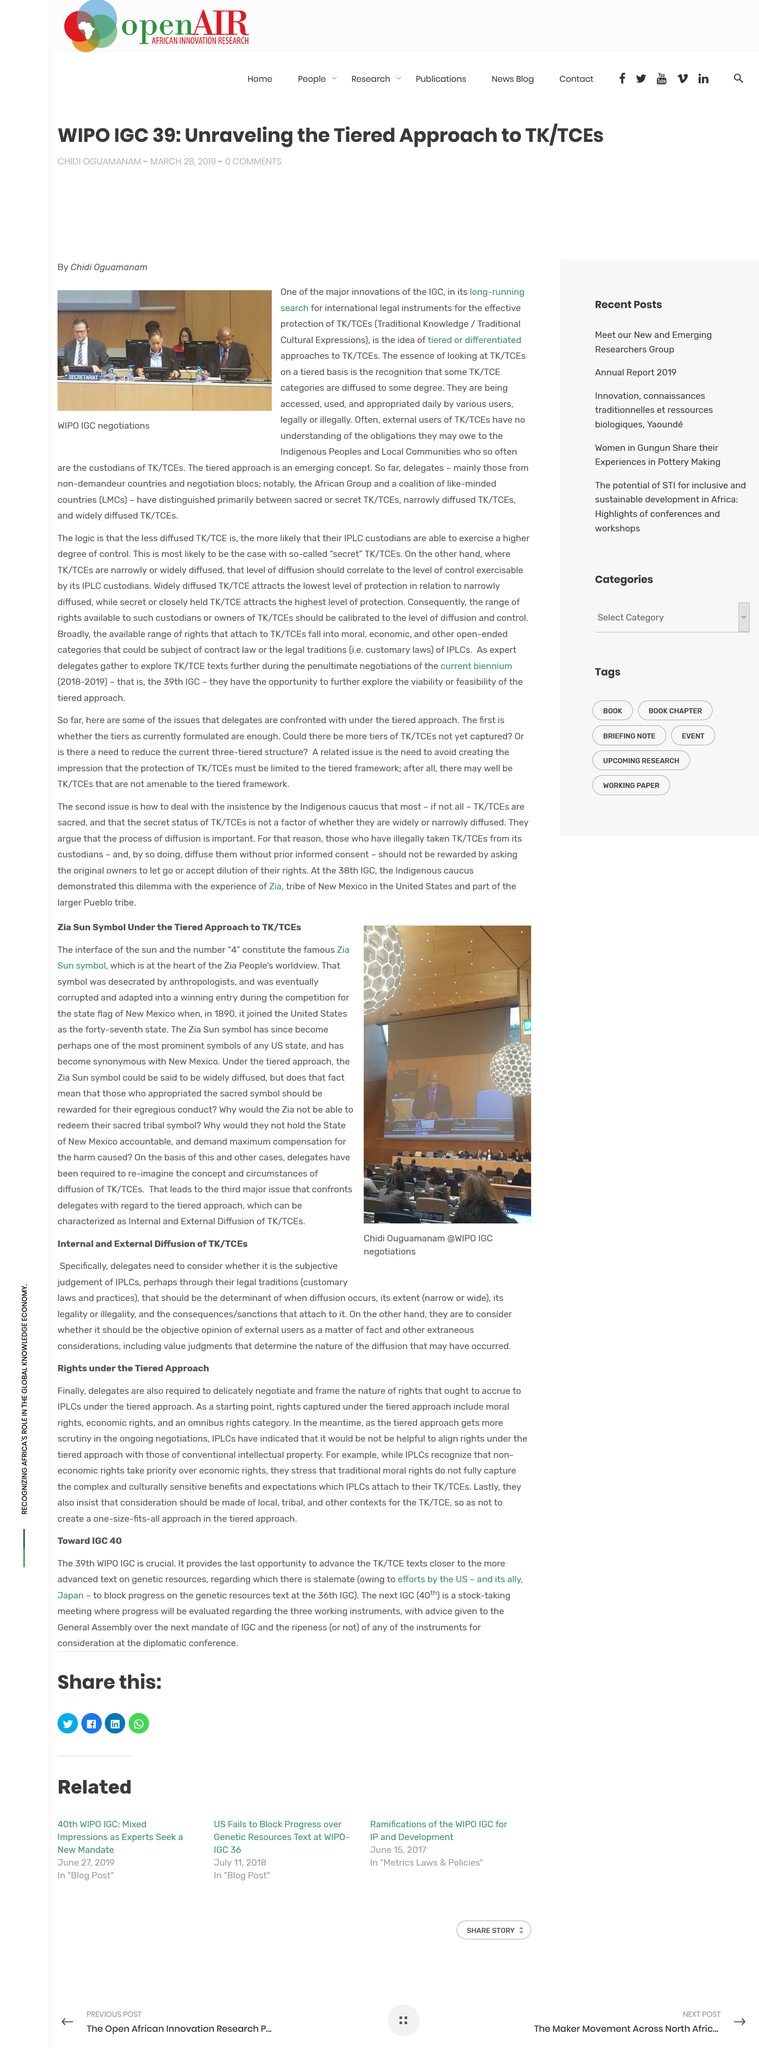Draw attention to some important aspects in this diagram. The topic at hand pertains to rights as determined by the tiered approach. The article mentions that the International Institute for Sustainable Development (IISD) is engaged in a long-running search for international legal instruments for the effective protection of Traditional Knowledge (TK) and Traditional Cultural Expressions (TCEs). The photograph accompanying the article can be seen to contain 4 people, when expressed as a numeral. Yes, moral rights are included in the rights captured under the tiered approach. In the abbreviation TK/TCE, each letter "T" stands for traditional. 